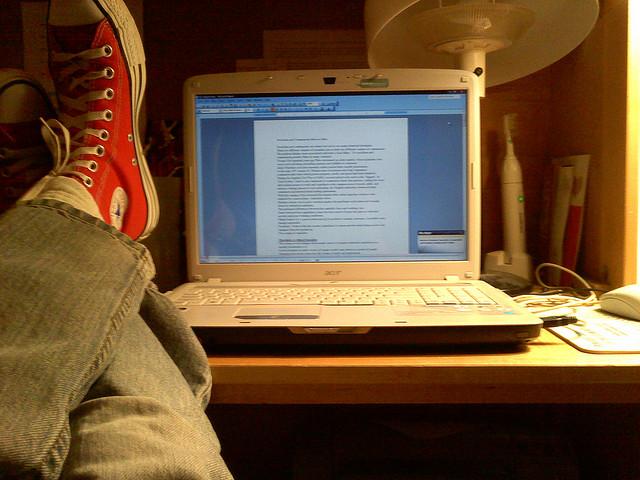What is on the screen?
Answer briefly. Words. Is the individual in the photo relaxed?
Keep it brief. Yes. What type of shoes is the person wearing?
Be succinct. Converse. 